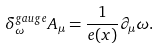Convert formula to latex. <formula><loc_0><loc_0><loc_500><loc_500>\delta _ { \omega } ^ { g a u g e } A _ { \mu } = \frac { 1 } { e ( x ) } \partial _ { \mu } \omega .</formula> 